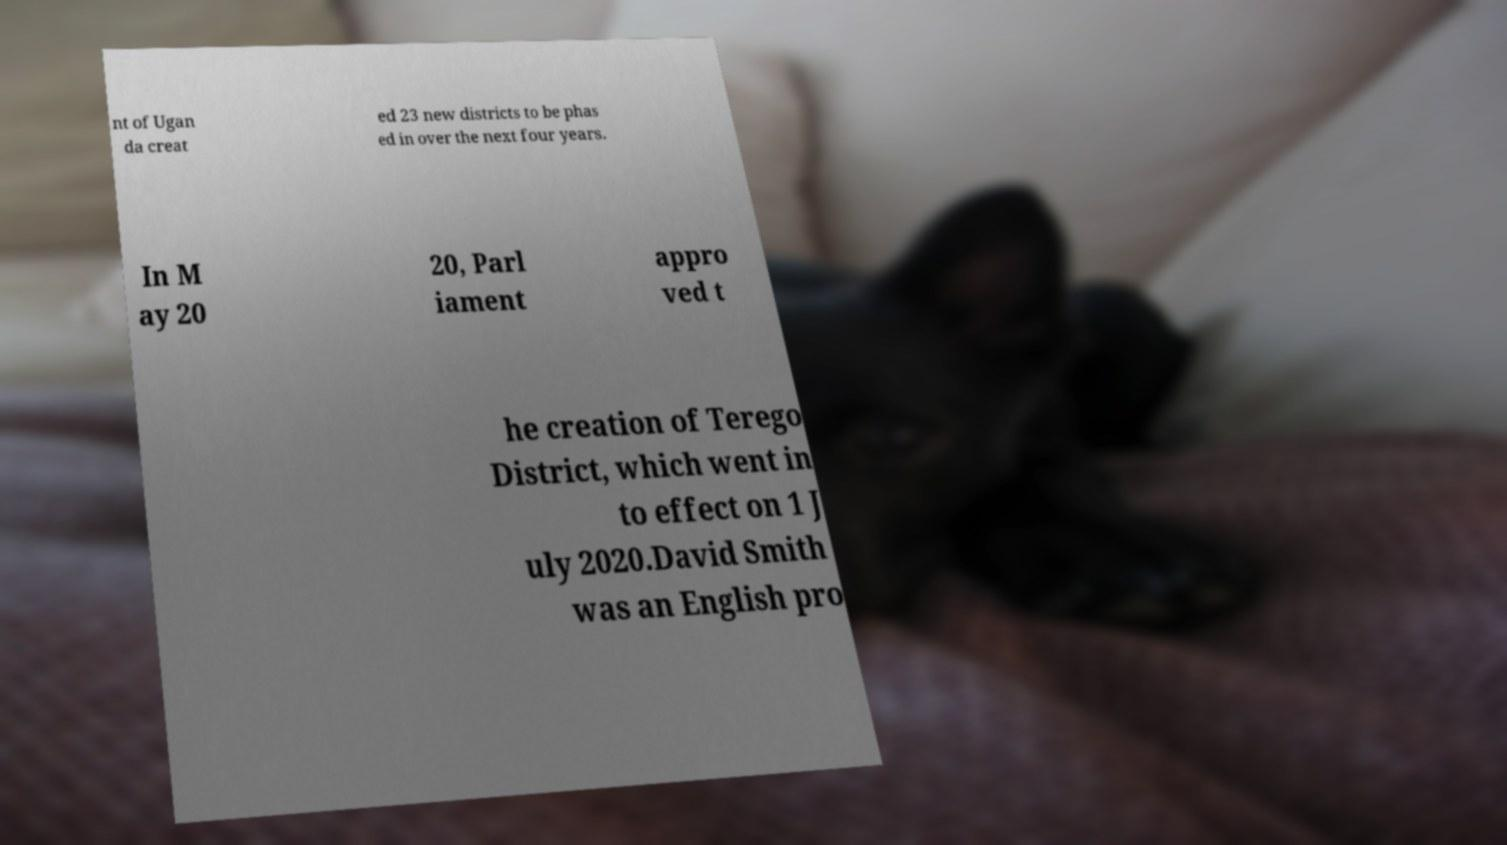Please read and relay the text visible in this image. What does it say? nt of Ugan da creat ed 23 new districts to be phas ed in over the next four years. In M ay 20 20, Parl iament appro ved t he creation of Terego District, which went in to effect on 1 J uly 2020.David Smith was an English pro 